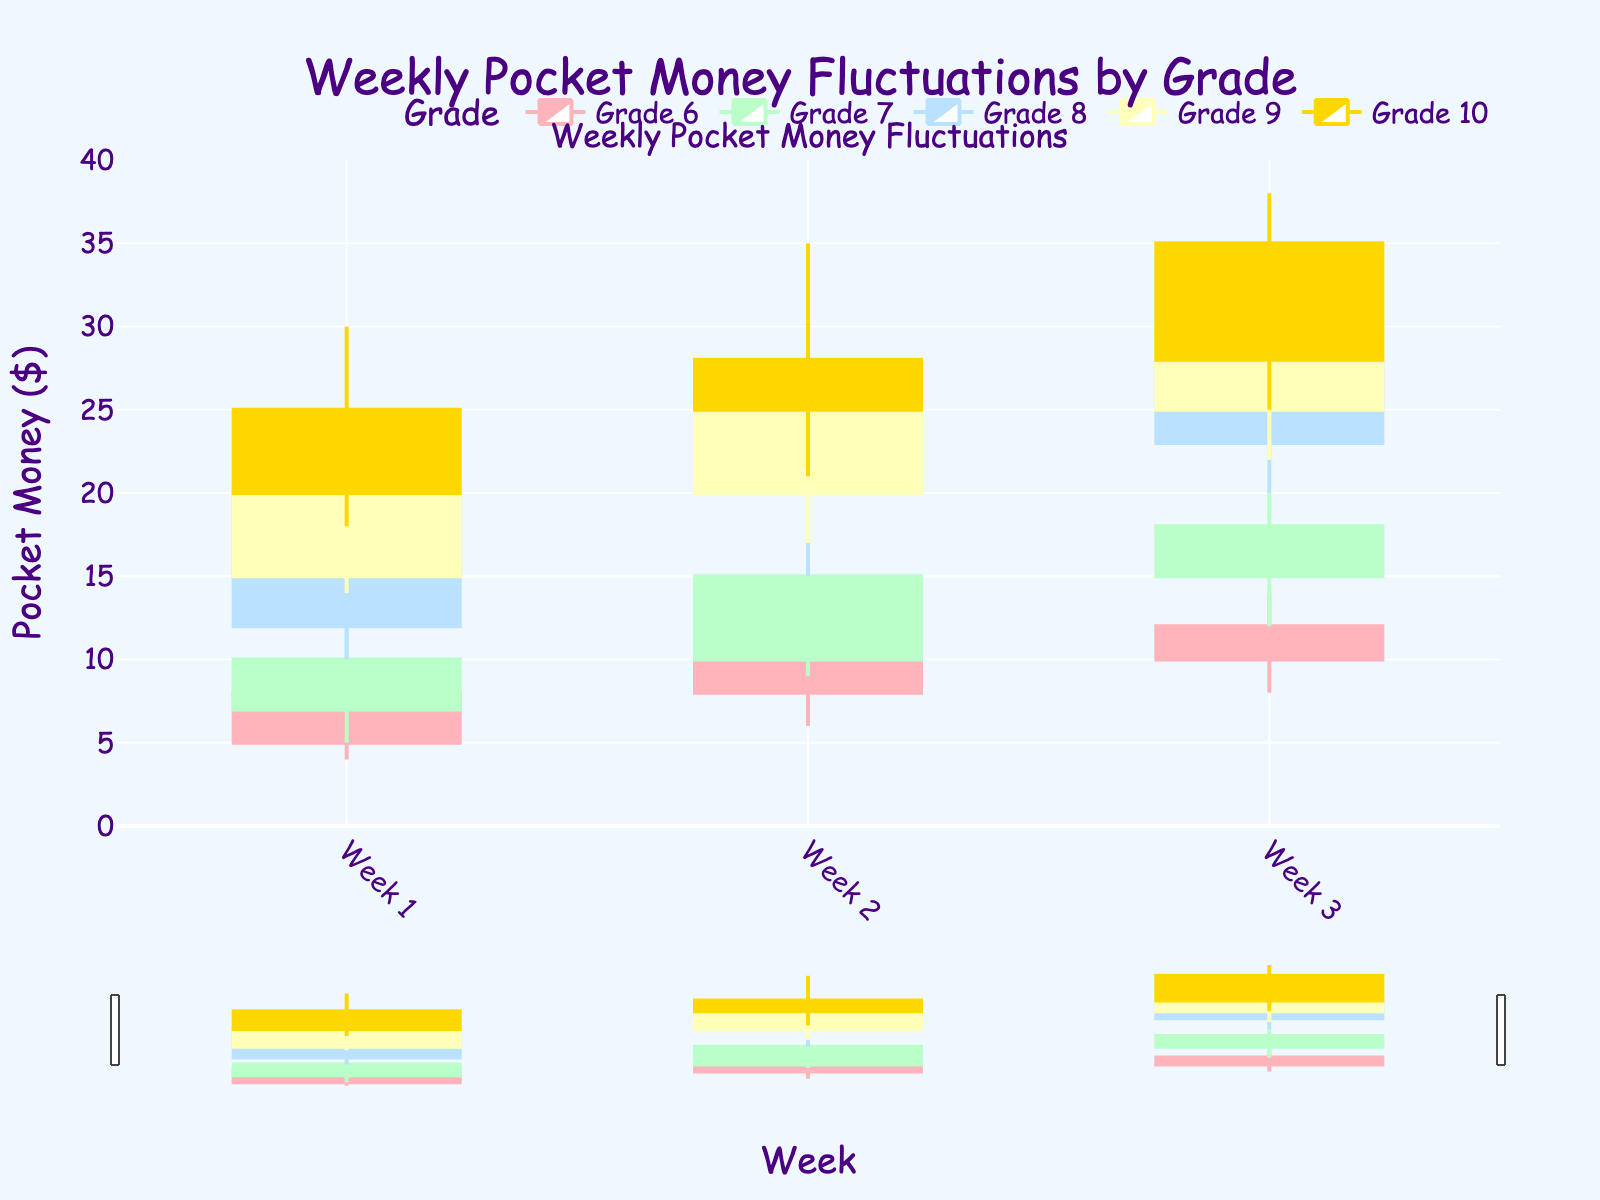What is the title of the plot? The title of the plot is located at the top center of the figure and is placed inside the plot's layout settings.
Answer: Weekly Pocket Money Fluctuations by Grade How many grades are compared in this chart? Each grade is represented by a candlestick grouping, and the legend at the top of the plot shows the number of compared grades.
Answer: 5 Which grade had the highest pocket money in Week 3? By examining the High values in Week 3 for all grades in the candlestick plot, the highest pocket money can be identified. Grade 9 had a High value of 35, which is the highest among all grades in Week 3.
Answer: Grade 9 What is the range of pocket money for Grade 8 in Week 2? The range is found by subtracting the Low value from the High value for that week. The High was 25, and the Low was 15, so the range is 25 - 15 = 10.
Answer: 10 How did the pocket money change from Week 1 to Week 3 for Grade 10? By comparing the Open value of Week 1 to the Close value of Week 3 for Grade 10, we can determine the change, where Open was 20 and Close was 35, leading to a change of 35 - 20 = 15.
Answer: Increased by 15 Which grade had the most consistent pocket money across all weeks? The consistency is determined by examining the low fluctuations in Open, High, Low, and Close values for each grade over all weeks. Grade 6 shows smaller fluctuations compared to other grades with high volatility in their pockets.
Answer: Grade 6 What is the total high pocket money recorded for all grades in Week 1? To find this, sum the High values for each grade in Week 1: 10 (Grade 6) + 15 (Grade 7) + 22 (Grade 8) + 25 (Grade 9) + 30 (Grade 10) = 102.
Answer: 102 Which grade generally had the highest increase in pocket money from Week 1 to Week 3? By comparing the difference in Close values from Week 1 to Week 3 for each grade, Grade 10 had the highest increase of 10-35 = 15.
Answer: Grade 10 